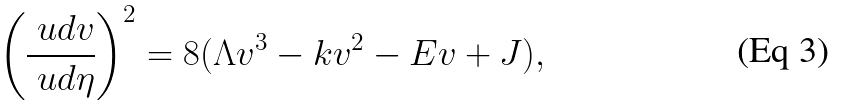Convert formula to latex. <formula><loc_0><loc_0><loc_500><loc_500>\left ( \frac { \ u d v } { \ u d \eta } \right ) ^ { 2 } = 8 ( \Lambda v ^ { 3 } - k v ^ { 2 } - E v + J ) ,</formula> 